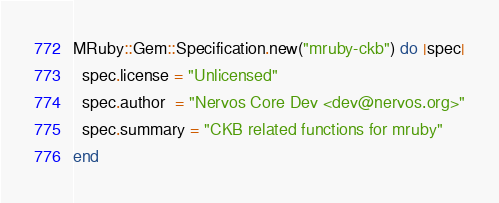<code> <loc_0><loc_0><loc_500><loc_500><_Ruby_>MRuby::Gem::Specification.new("mruby-ckb") do |spec|
  spec.license = "Unlicensed"
  spec.author  = "Nervos Core Dev <dev@nervos.org>"
  spec.summary = "CKB related functions for mruby"
end
</code> 